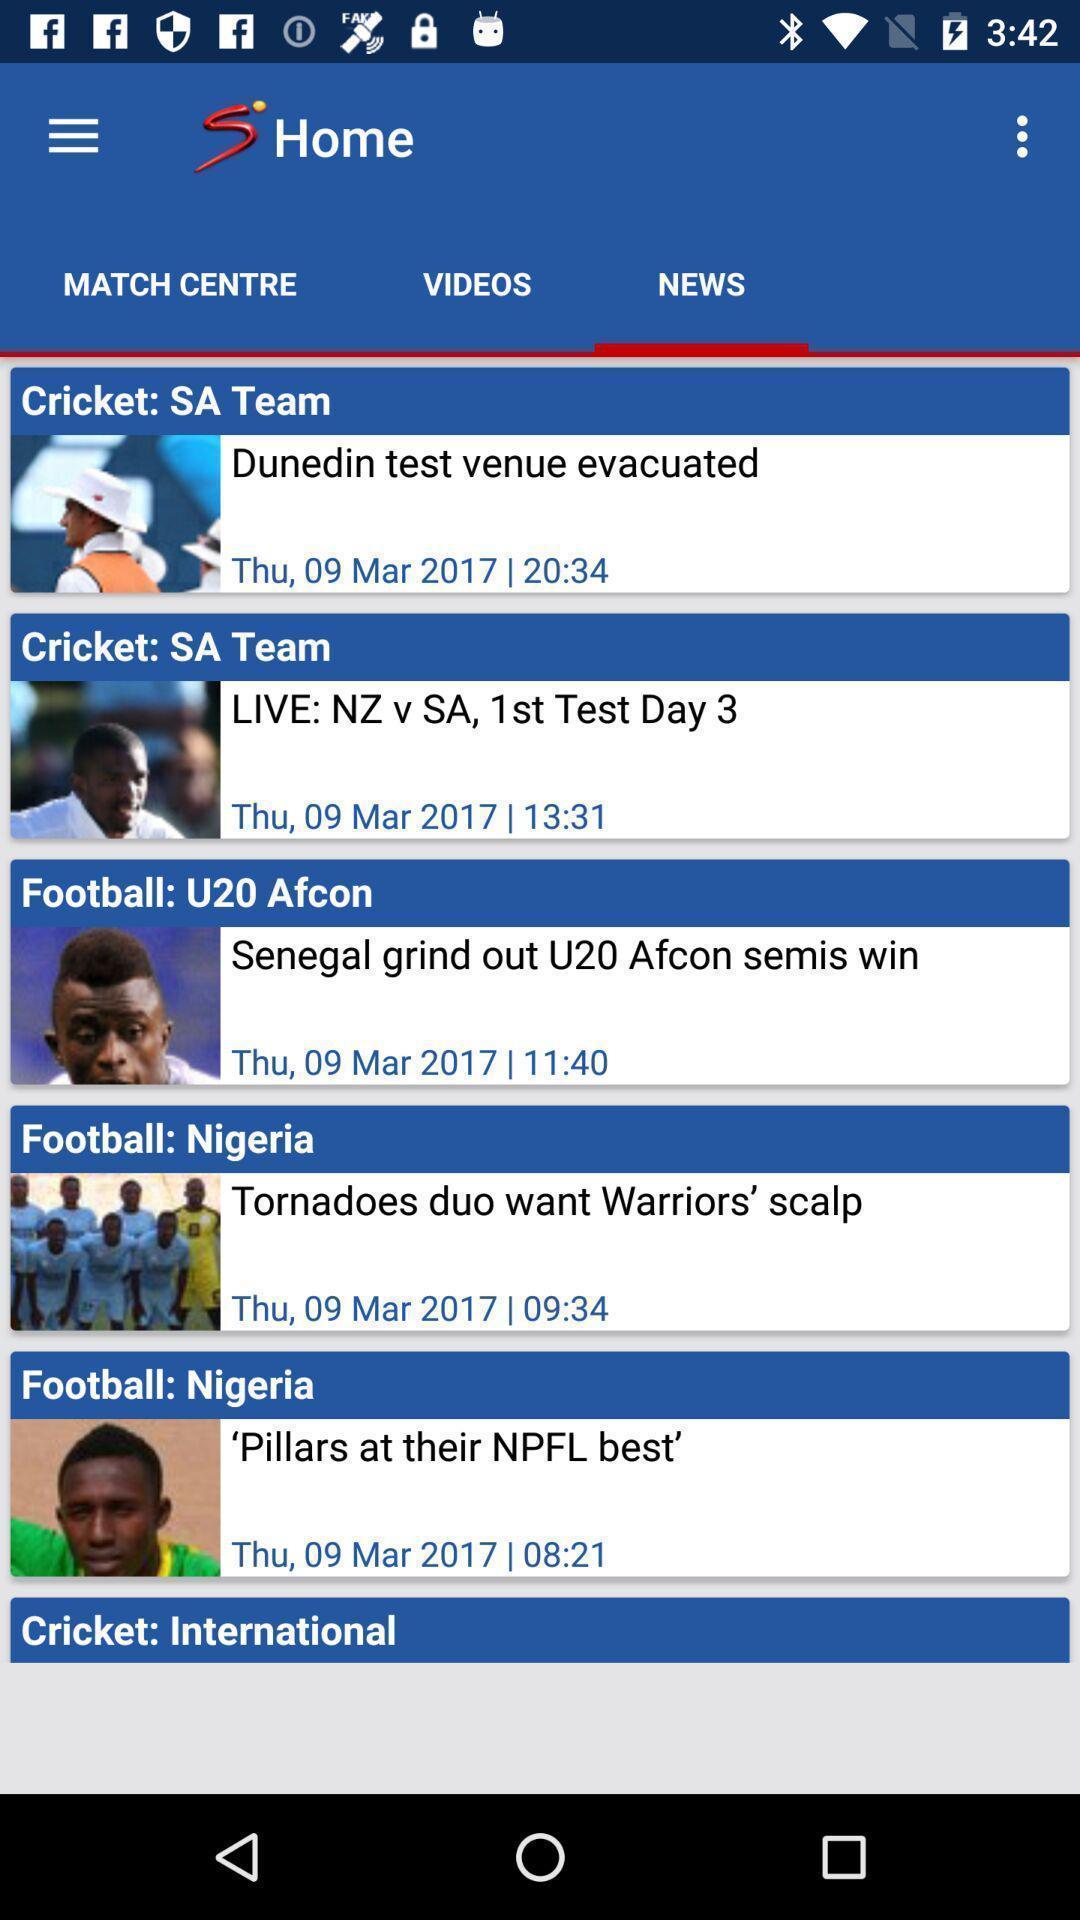What can you discern from this picture? Screen showing news page of an entertainment app. 